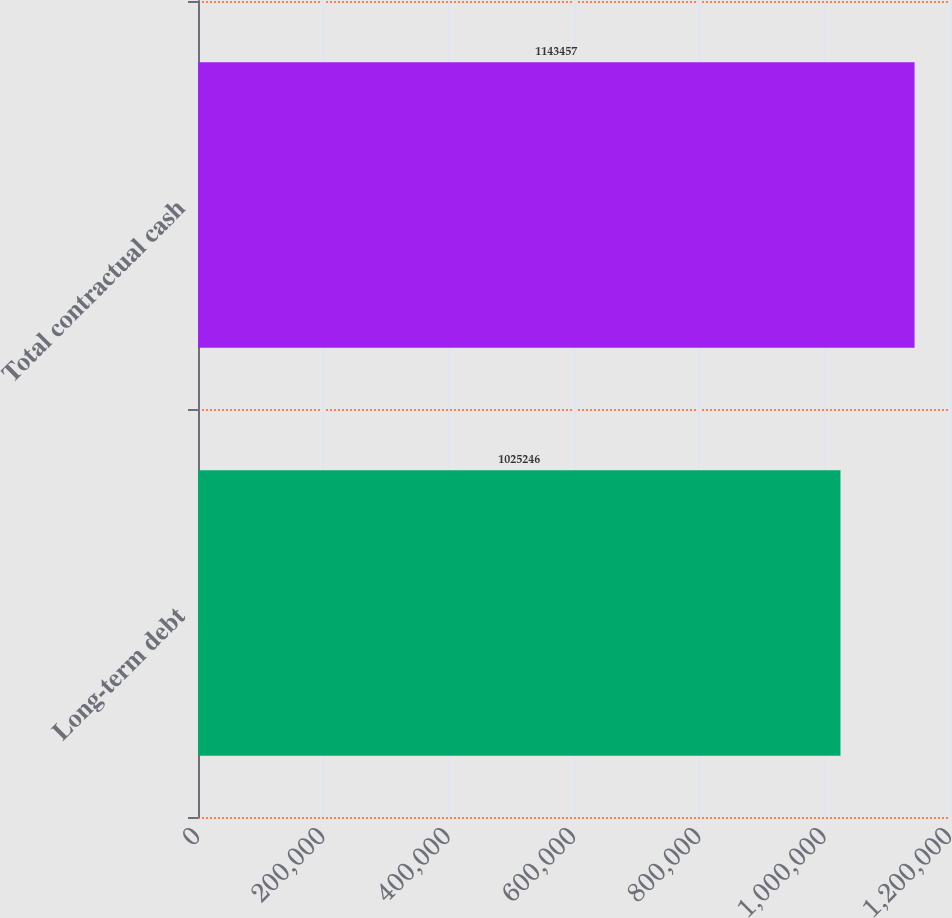Convert chart. <chart><loc_0><loc_0><loc_500><loc_500><bar_chart><fcel>Long-term debt<fcel>Total contractual cash<nl><fcel>1.02525e+06<fcel>1.14346e+06<nl></chart> 